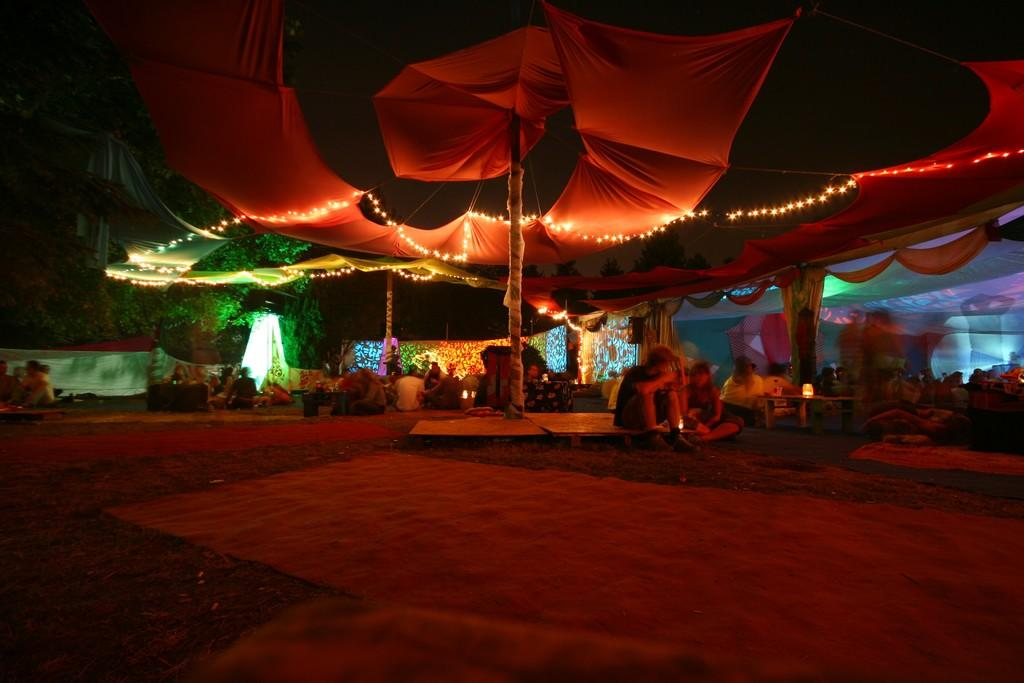What are the people in the image doing? The people in the image are sitting on the ground. What can be seen on the left side of the image? There are trees on the left side of the image. What type of cup can be seen hanging from the trees in the image? There is no cup present in the image, and no cups are hanging from the trees. 